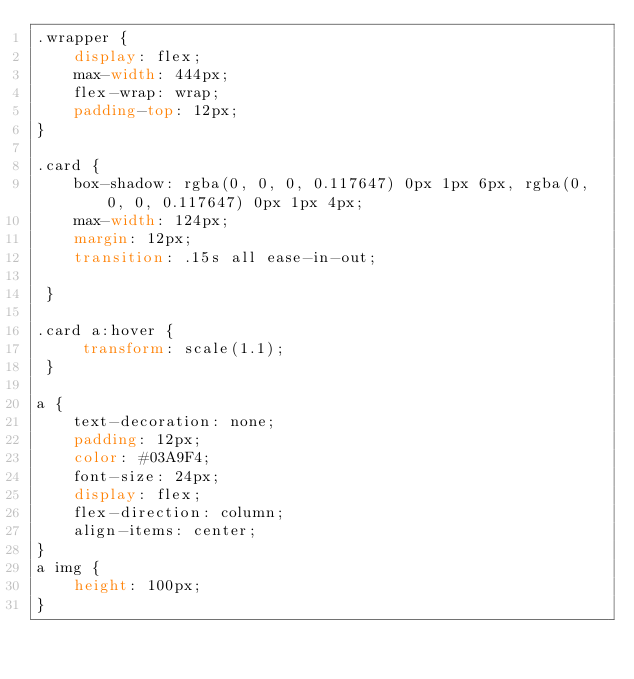Convert code to text. <code><loc_0><loc_0><loc_500><loc_500><_CSS_>.wrapper {
    display: flex;
    max-width: 444px;
    flex-wrap: wrap;
    padding-top: 12px;
}

.card {
    box-shadow: rgba(0, 0, 0, 0.117647) 0px 1px 6px, rgba(0, 0, 0, 0.117647) 0px 1px 4px;
    max-width: 124px;
    margin: 12px;
    transition: .15s all ease-in-out;

 }

.card a:hover {
     transform: scale(1.1);
 }

a {
    text-decoration: none;
    padding: 12px;
    color: #03A9F4;
    font-size: 24px;
    display: flex;
    flex-direction: column;
    align-items: center;
}
a img {
    height: 100px;
}</code> 